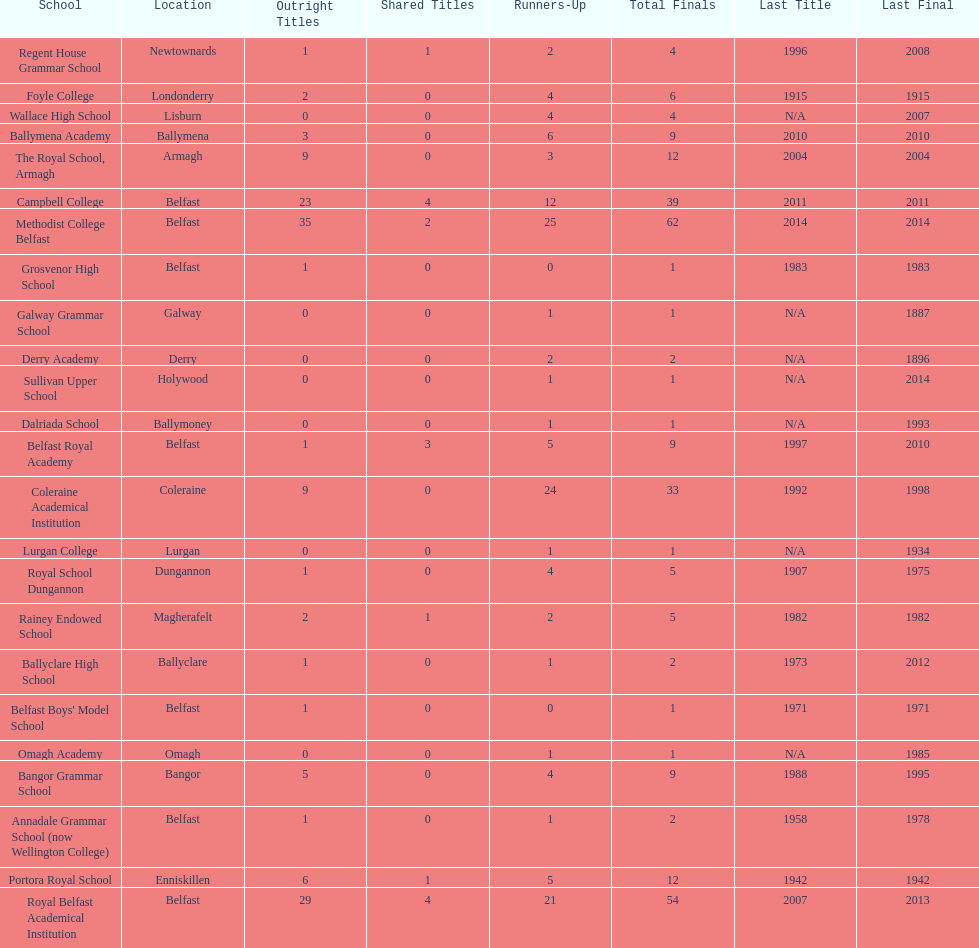What is the difference in runners-up from coleraine academical institution and royal school dungannon? 20. Parse the full table. {'header': ['School', 'Location', 'Outright Titles', 'Shared Titles', 'Runners-Up', 'Total Finals', 'Last Title', 'Last Final'], 'rows': [['Regent House Grammar School', 'Newtownards', '1', '1', '2', '4', '1996', '2008'], ['Foyle College', 'Londonderry', '2', '0', '4', '6', '1915', '1915'], ['Wallace High School', 'Lisburn', '0', '0', '4', '4', 'N/A', '2007'], ['Ballymena Academy', 'Ballymena', '3', '0', '6', '9', '2010', '2010'], ['The Royal School, Armagh', 'Armagh', '9', '0', '3', '12', '2004', '2004'], ['Campbell College', 'Belfast', '23', '4', '12', '39', '2011', '2011'], ['Methodist College Belfast', 'Belfast', '35', '2', '25', '62', '2014', '2014'], ['Grosvenor High School', 'Belfast', '1', '0', '0', '1', '1983', '1983'], ['Galway Grammar School', 'Galway', '0', '0', '1', '1', 'N/A', '1887'], ['Derry Academy', 'Derry', '0', '0', '2', '2', 'N/A', '1896'], ['Sullivan Upper School', 'Holywood', '0', '0', '1', '1', 'N/A', '2014'], ['Dalriada School', 'Ballymoney', '0', '0', '1', '1', 'N/A', '1993'], ['Belfast Royal Academy', 'Belfast', '1', '3', '5', '9', '1997', '2010'], ['Coleraine Academical Institution', 'Coleraine', '9', '0', '24', '33', '1992', '1998'], ['Lurgan College', 'Lurgan', '0', '0', '1', '1', 'N/A', '1934'], ['Royal School Dungannon', 'Dungannon', '1', '0', '4', '5', '1907', '1975'], ['Rainey Endowed School', 'Magherafelt', '2', '1', '2', '5', '1982', '1982'], ['Ballyclare High School', 'Ballyclare', '1', '0', '1', '2', '1973', '2012'], ["Belfast Boys' Model School", 'Belfast', '1', '0', '0', '1', '1971', '1971'], ['Omagh Academy', 'Omagh', '0', '0', '1', '1', 'N/A', '1985'], ['Bangor Grammar School', 'Bangor', '5', '0', '4', '9', '1988', '1995'], ['Annadale Grammar School (now Wellington College)', 'Belfast', '1', '0', '1', '2', '1958', '1978'], ['Portora Royal School', 'Enniskillen', '6', '1', '5', '12', '1942', '1942'], ['Royal Belfast Academical Institution', 'Belfast', '29', '4', '21', '54', '2007', '2013']]} 